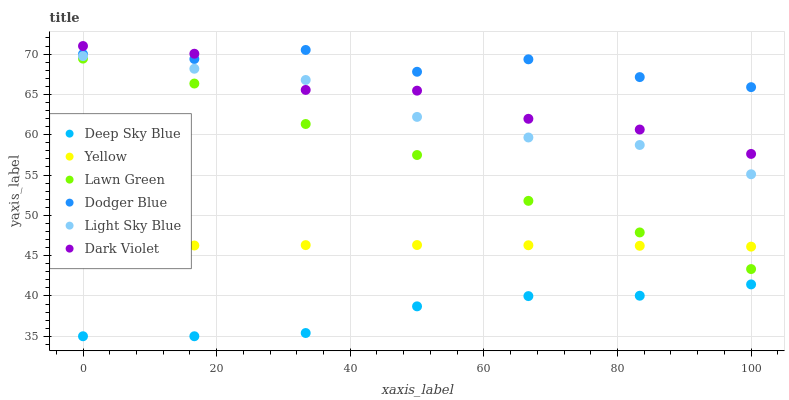Does Deep Sky Blue have the minimum area under the curve?
Answer yes or no. Yes. Does Dodger Blue have the maximum area under the curve?
Answer yes or no. Yes. Does Dark Violet have the minimum area under the curve?
Answer yes or no. No. Does Dark Violet have the maximum area under the curve?
Answer yes or no. No. Is Yellow the smoothest?
Answer yes or no. Yes. Is Dark Violet the roughest?
Answer yes or no. Yes. Is Light Sky Blue the smoothest?
Answer yes or no. No. Is Light Sky Blue the roughest?
Answer yes or no. No. Does Deep Sky Blue have the lowest value?
Answer yes or no. Yes. Does Dark Violet have the lowest value?
Answer yes or no. No. Does Dark Violet have the highest value?
Answer yes or no. Yes. Does Light Sky Blue have the highest value?
Answer yes or no. No. Is Lawn Green less than Dark Violet?
Answer yes or no. Yes. Is Light Sky Blue greater than Lawn Green?
Answer yes or no. Yes. Does Dark Violet intersect Dodger Blue?
Answer yes or no. Yes. Is Dark Violet less than Dodger Blue?
Answer yes or no. No. Is Dark Violet greater than Dodger Blue?
Answer yes or no. No. Does Lawn Green intersect Dark Violet?
Answer yes or no. No. 